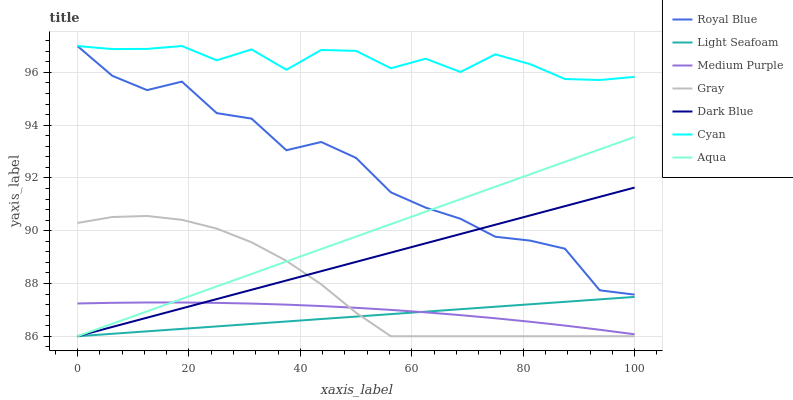Does Light Seafoam have the minimum area under the curve?
Answer yes or no. Yes. Does Cyan have the maximum area under the curve?
Answer yes or no. Yes. Does Dark Blue have the minimum area under the curve?
Answer yes or no. No. Does Dark Blue have the maximum area under the curve?
Answer yes or no. No. Is Aqua the smoothest?
Answer yes or no. Yes. Is Royal Blue the roughest?
Answer yes or no. Yes. Is Dark Blue the smoothest?
Answer yes or no. No. Is Dark Blue the roughest?
Answer yes or no. No. Does Gray have the lowest value?
Answer yes or no. Yes. Does Medium Purple have the lowest value?
Answer yes or no. No. Does Cyan have the highest value?
Answer yes or no. Yes. Does Dark Blue have the highest value?
Answer yes or no. No. Is Aqua less than Cyan?
Answer yes or no. Yes. Is Cyan greater than Gray?
Answer yes or no. Yes. Does Dark Blue intersect Royal Blue?
Answer yes or no. Yes. Is Dark Blue less than Royal Blue?
Answer yes or no. No. Is Dark Blue greater than Royal Blue?
Answer yes or no. No. Does Aqua intersect Cyan?
Answer yes or no. No. 